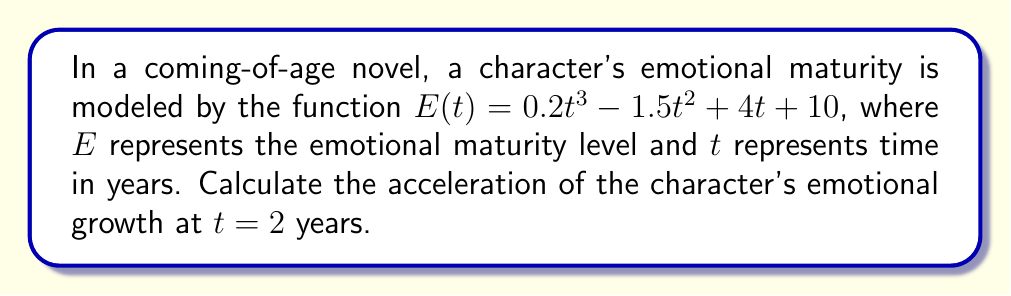Show me your answer to this math problem. To find the acceleration of the character's emotional growth, we need to calculate the second derivative of the given function $E(t)$.

Step 1: Find the first derivative (velocity of emotional growth)
$$\frac{dE}{dt} = E'(t) = 0.6t^2 - 3t + 4$$

Step 2: Find the second derivative (acceleration of emotional growth)
$$\frac{d^2E}{dt^2} = E''(t) = 1.2t - 3$$

Step 3: Evaluate the second derivative at $t = 2$
$$E''(2) = 1.2(2) - 3 = 2.4 - 3 = -0.6$$

The negative value indicates that the character's emotional growth is decelerating at $t = 2$ years.
Answer: $-0.6$ 